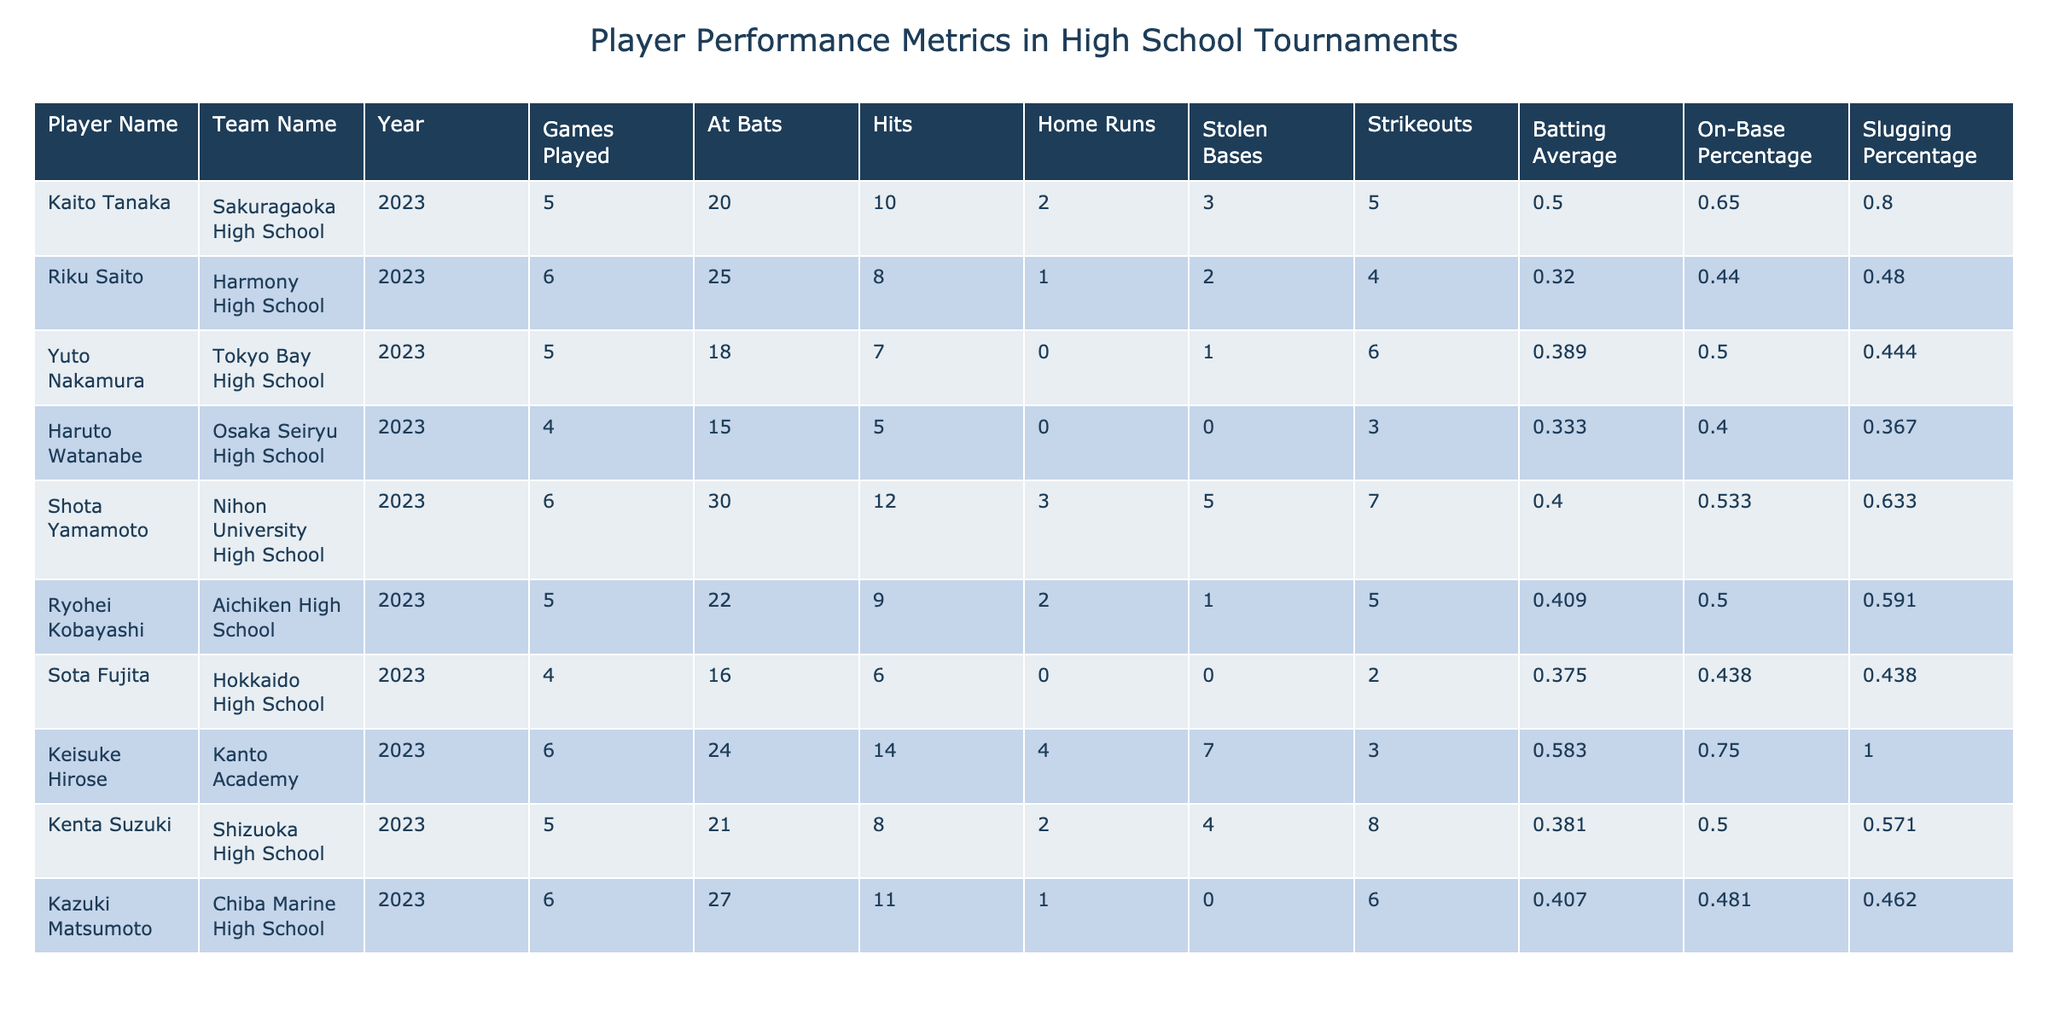What is the batting average of Kaito Tanaka? Kaito Tanaka's batting average is listed in the table under the Batting Average column. According to the data, it shows a batting average of 0.500.
Answer: 0.500 Which player has the highest slugging percentage? To determine the highest slugging percentage, we compare the Slugging Percentage column for all players. Keisuke Hirose has the highest slugging percentage at 1.000.
Answer: 1.000 How many home runs did Yuto Nakamura hit? The table shows that Yuto Nakamura is listed under the Home Runs column. His data indicate that he hit 0 home runs.
Answer: 0 What is the total number of stolen bases by players from Team Name "Sakuragaoka High School"? To find the total stolen bases for players from "Sakuragaoka High School," we look at Kaito Tanaka's row. He has 3 stolen bases, and since he is the only player from that team in the data, the total is 3.
Answer: 3 Is Riku Saito's on-base percentage higher than that of Haruto Watanabe? We compare the On-Base Percentage column for Riku Saito and Haruto Watanabe. Riku Saito's on-base percentage is 0.440, while Haruto Watanabe's is 0.400. Since 0.440 is greater than 0.400, the statement is true.
Answer: Yes What is the combined number of hits for all players? To find the combined number of hits, we sum up the Hits column values: 10 + 8 + 7 + 5 + 12 + 9 + 6 + 14 + 8 + 11 = 90. The combined number of hits is 90.
Answer: 90 Who has the most stolen bases and how many did he steal? We look through the Stolen Bases column for the highest value. Keisuke Hirose has 7 stolen bases, which is the highest among all players.
Answer: Keisuke Hirose, 7 What is the average batting average of all players? To calculate the average batting average, add up all batting averages: 0.500 + 0.320 + 0.389 + 0.333 + 0.400 + 0.409 + 0.375 + 0.583 + 0.381 + 0.407 = 4.466. Then divide by the number of players (10): 4.466 / 10 = 0.4466. The average batting average is approximately 0.447.
Answer: 0.447 How many players have a batting average above 0.400? By checking the Batting Average column, we find the players with averages above 0.400: Kaito Tanaka (0.500), Shota Yamamoto (0.400), Ryohei Kobayashi (0.409), and Keisuke Hirose (0.583). Thus, there are 4 players with a batting average above 0.400.
Answer: 4 